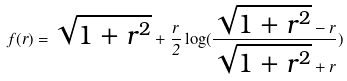<formula> <loc_0><loc_0><loc_500><loc_500>f ( r ) = \sqrt { 1 + r ^ { 2 } } + \frac { r } { 2 } \log ( \frac { \sqrt { 1 + r ^ { 2 } } - r } { \sqrt { 1 + r ^ { 2 } } + r } )</formula> 